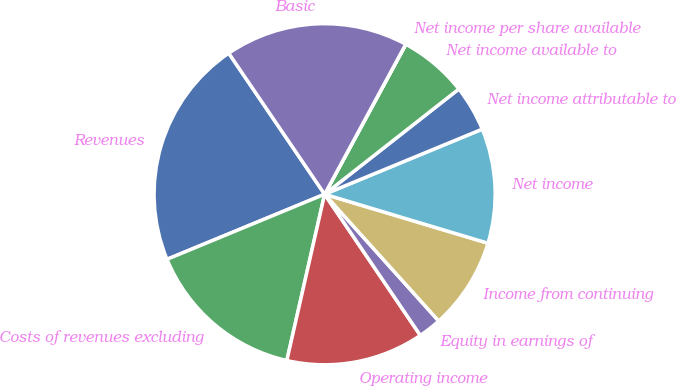Convert chart to OTSL. <chart><loc_0><loc_0><loc_500><loc_500><pie_chart><fcel>Revenues<fcel>Costs of revenues excluding<fcel>Operating income<fcel>Equity in earnings of<fcel>Income from continuing<fcel>Net income<fcel>Net income attributable to<fcel>Net income available to<fcel>Net income per share available<fcel>Basic<nl><fcel>21.73%<fcel>15.21%<fcel>13.04%<fcel>2.18%<fcel>8.7%<fcel>10.87%<fcel>4.35%<fcel>6.52%<fcel>0.01%<fcel>17.39%<nl></chart> 